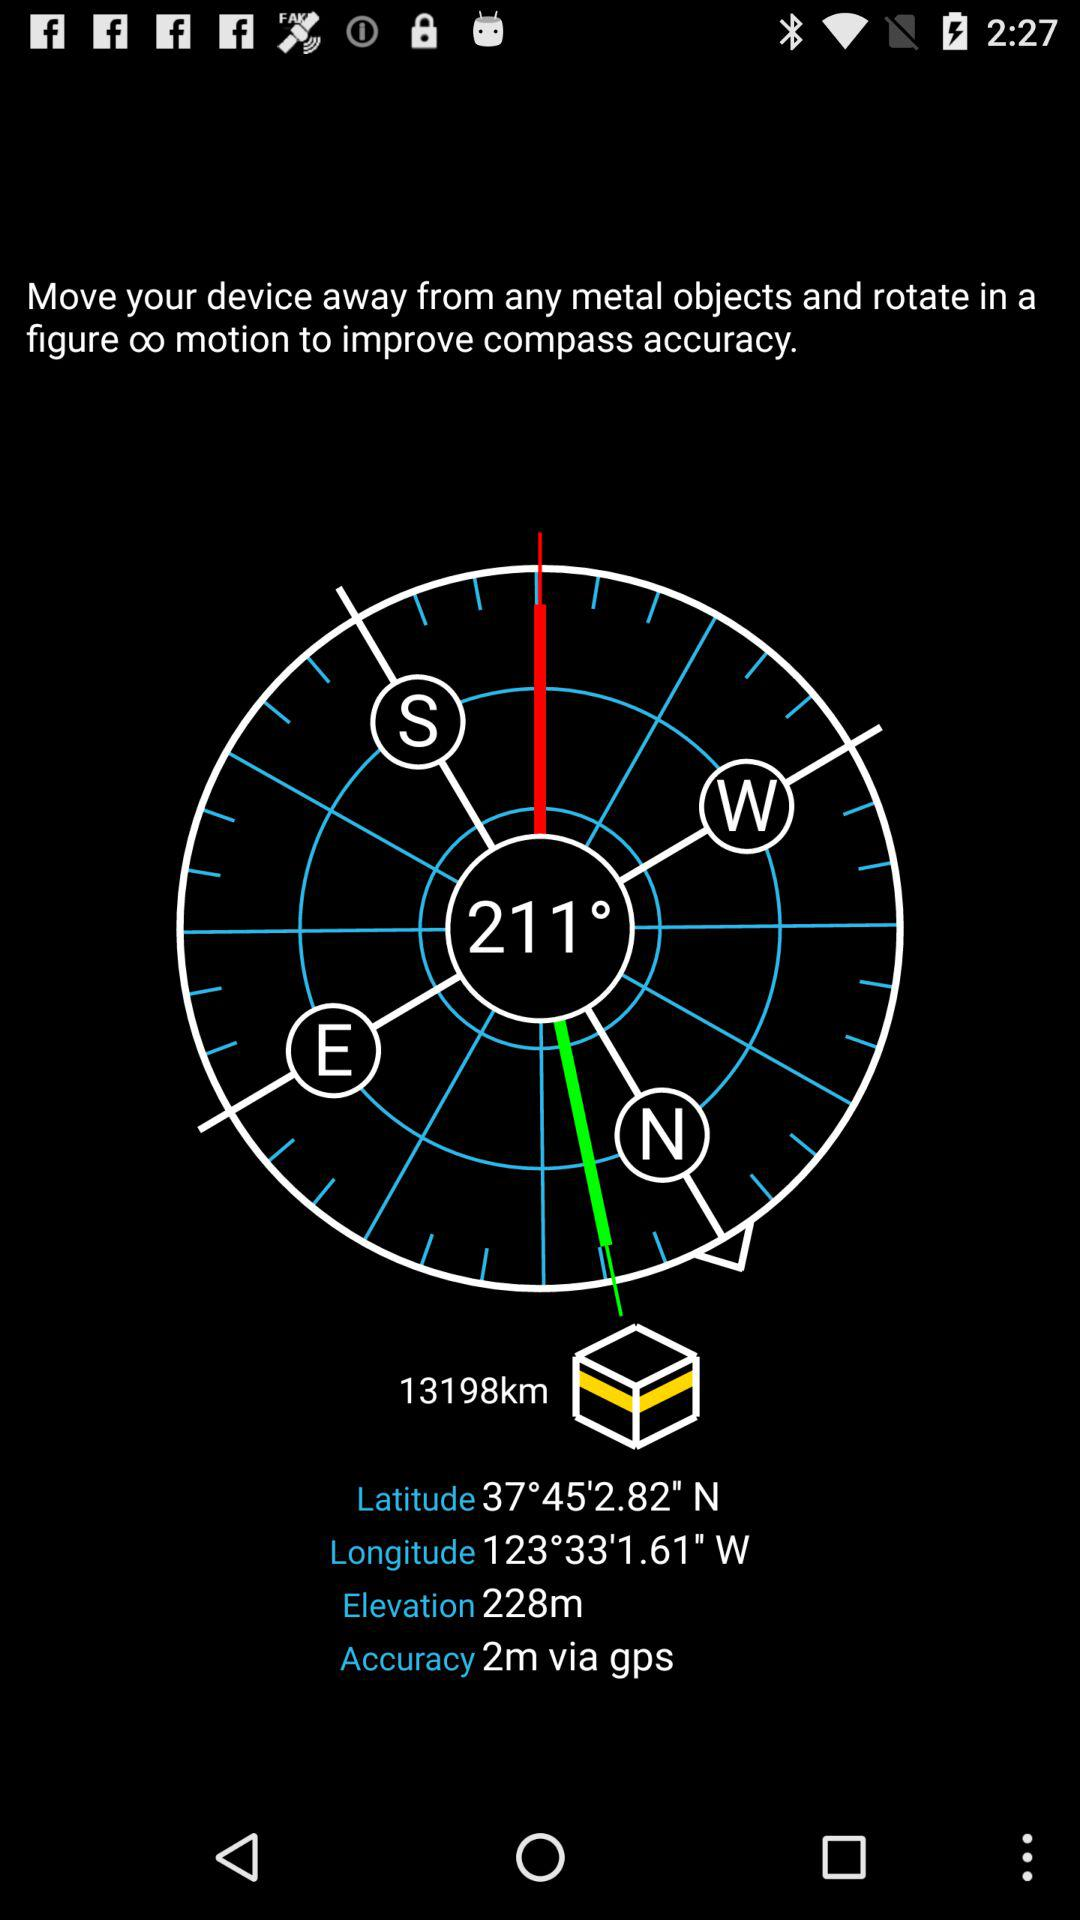What is the elevation? The elevation is 228 m. 